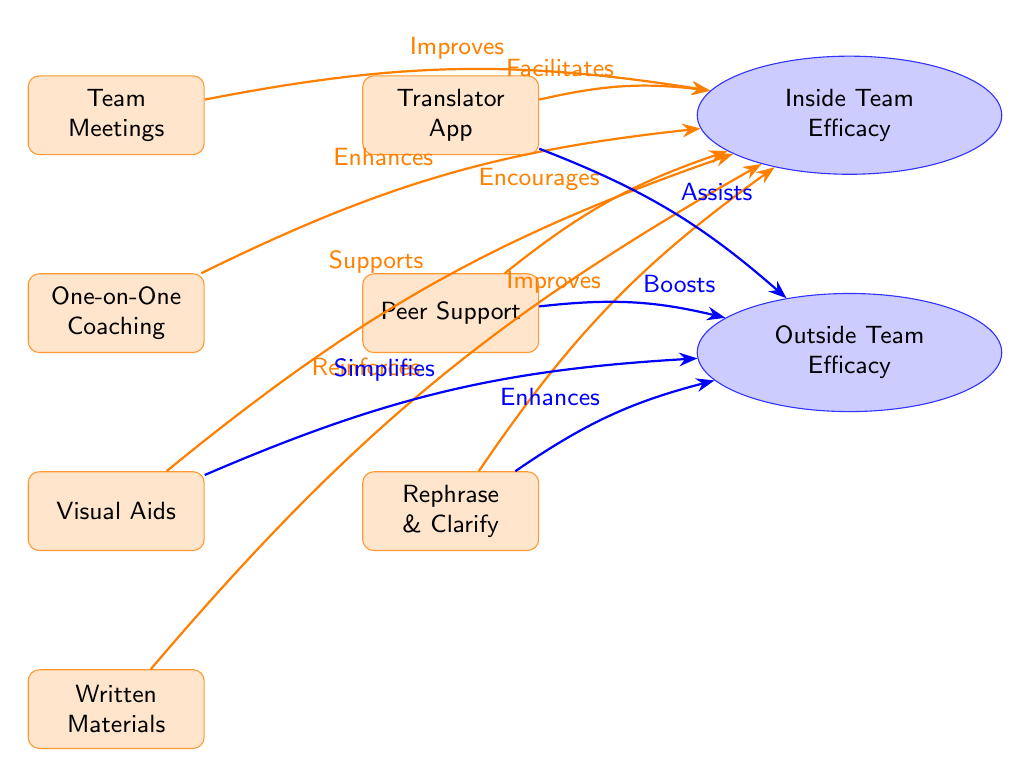What are the techniques listed for team communication? The diagram lists six techniques for team communication: Team Meetings, One-on-One Coaching, Visual Aids, Written Materials, Translator App, Peer Support, and Rephrase & Clarify.
Answer: Team Meetings, One-on-One Coaching, Visual Aids, Written Materials, Translator App, Peer Support, Rephrase & Clarify How many efficacy nodes are in the diagram? There are two efficacy nodes in the diagram: Inside Team Efficacy and Outside Team Efficacy.
Answer: 2 Which technique is associated with the relationship "Encourages"? The technique associated with "Encourages" is Peer Support, as denoted in the arrow connecting it to Inside Team Efficacy.
Answer: Peer Support How does Visual Aids impact Inside Team Efficacy? Visual Aids "Supports" Inside Team Efficacy according to the arrow connecting these two components in the diagram.
Answer: Supports What is the relationship of Translator App to Outside Team Efficacy? The Translator App "Assists" Outside Team Efficacy, as stated by the arrow leading from the Translator App to Outside Team Efficacy.
Answer: Assists What is the effect of Written Materials on Inside Team Efficacy? Written Materials "Reinforces" Inside Team Efficacy, which is shown by the directed arrow linking these elements in the diagram.
Answer: Reinforces Which technique is the lowest node in its section of the diagram? The lowest technique in its section is Rephrase & Clarify, as it is positioned at the bottom of the group of communication techniques listed.
Answer: Rephrase & Clarify Which node connects to both Inside Team Efficacy and Outside Team Efficacy? Visual Aids connects to both Inside Team Efficacy (by supporting it) and Outside Team Efficacy (by simplifying it).
Answer: Visual Aids What are the two arrows that come from the Rephrase & Clarify technique? The two arrows that come from the Rephrase & Clarify technique are "Improves" towards Inside Team Efficacy and does not lead directly to any Outside Team Efficacy node.
Answer: Improves 